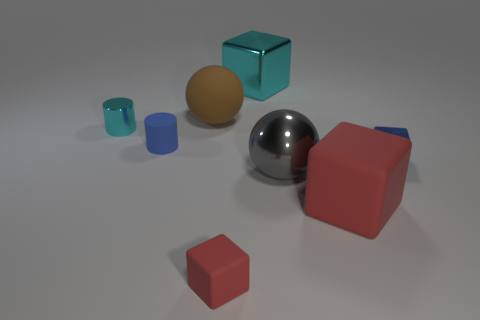What number of green things are metallic cubes or matte blocks?
Provide a succinct answer. 0. What is the shape of the red object right of the large cube that is behind the large shiny ball?
Offer a very short reply. Cube. Does the cylinder that is behind the small blue matte cylinder have the same size as the cyan thing that is to the right of the brown matte object?
Keep it short and to the point. No. Is there a big gray object that has the same material as the big red cube?
Give a very brief answer. No. There is a thing that is the same color as the small metallic cube; what is its size?
Give a very brief answer. Small. There is a tiny cube behind the rubber block that is left of the big metal cube; are there any shiny blocks that are right of it?
Keep it short and to the point. No. Are there any tiny red matte cubes behind the rubber sphere?
Give a very brief answer. No. How many blue metallic cubes are to the right of the small cyan cylinder that is in front of the cyan metal block?
Make the answer very short. 1. Do the blue rubber thing and the cylinder behind the small blue matte object have the same size?
Your response must be concise. Yes. Is there a metallic thing that has the same color as the small shiny cube?
Provide a succinct answer. No. 